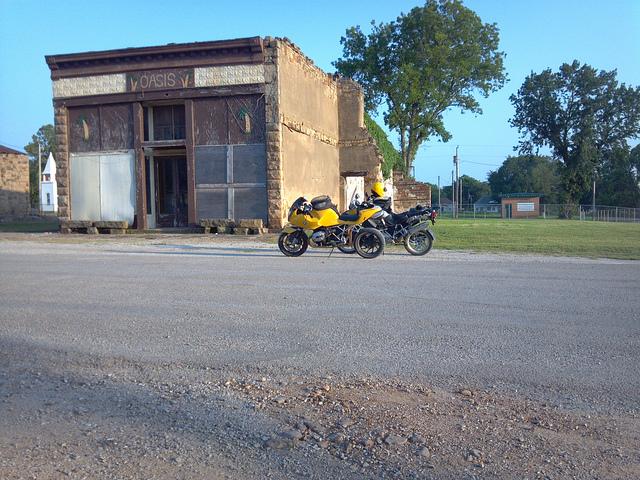Are both bikes yellow?
Concise answer only. No. How many bikes are in the photo?
Keep it brief. 2. What are the vehicles?
Be succinct. Motorcycles. 